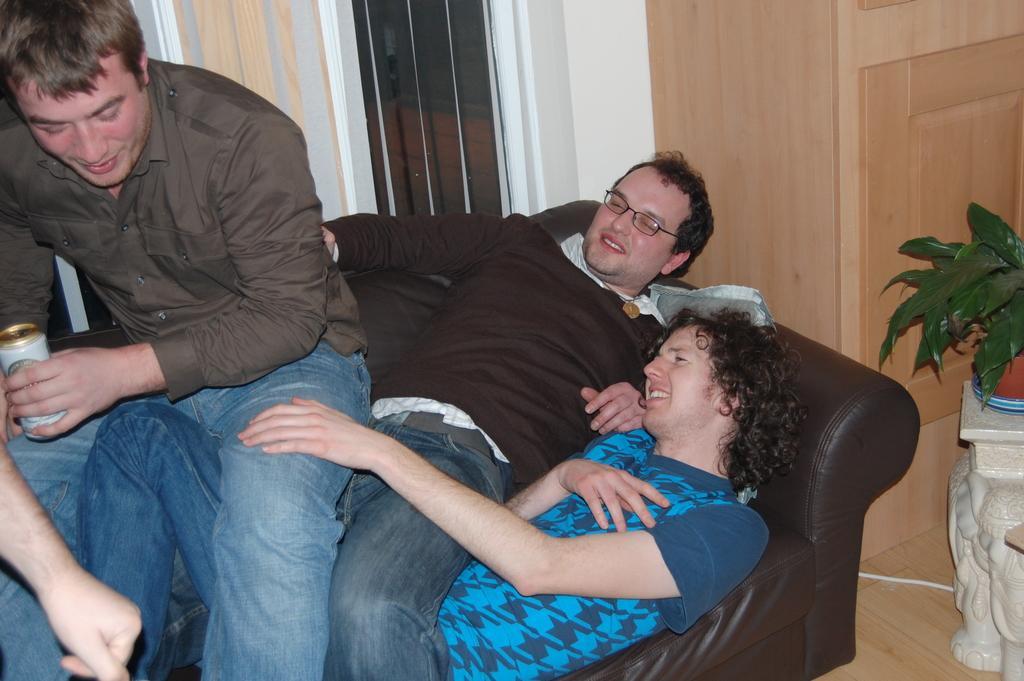Please provide a concise description of this image. Here in this picture we can see couple of men laying on the couch over there and we can see another person trying to sit on them and all of them are smiling and the person in the front is holding a tin in his hand and beside them we can see a plant present on the floor over there and behind them we can see a door present over there. 